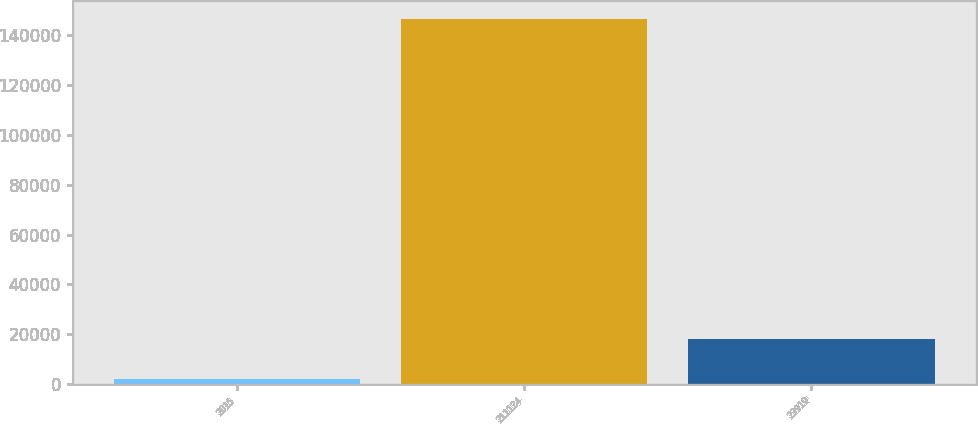Convert chart to OTSL. <chart><loc_0><loc_0><loc_500><loc_500><bar_chart><fcel>2015<fcel>211124<fcel>23919<nl><fcel>2013<fcel>146544<fcel>18210<nl></chart> 